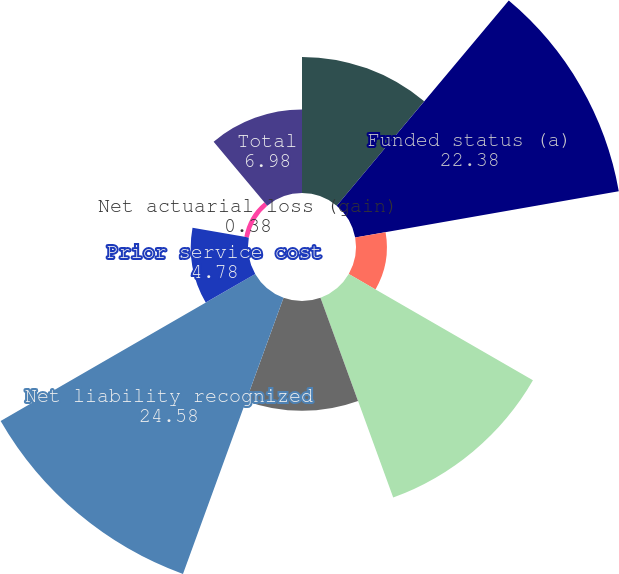Convert chart. <chart><loc_0><loc_0><loc_500><loc_500><pie_chart><fcel>December 31 (In millions)<fcel>Funded status (a)<fcel>Due within one year<fcel>Due after one year<fcel>R e t i r e el i f ep l a n s<fcel>Net liability recognized<fcel>Prior service cost<fcel>Net actuarial loss (gain)<fcel>Total<nl><fcel>11.38%<fcel>22.38%<fcel>2.58%<fcel>17.78%<fcel>9.18%<fcel>24.58%<fcel>4.78%<fcel>0.38%<fcel>6.98%<nl></chart> 